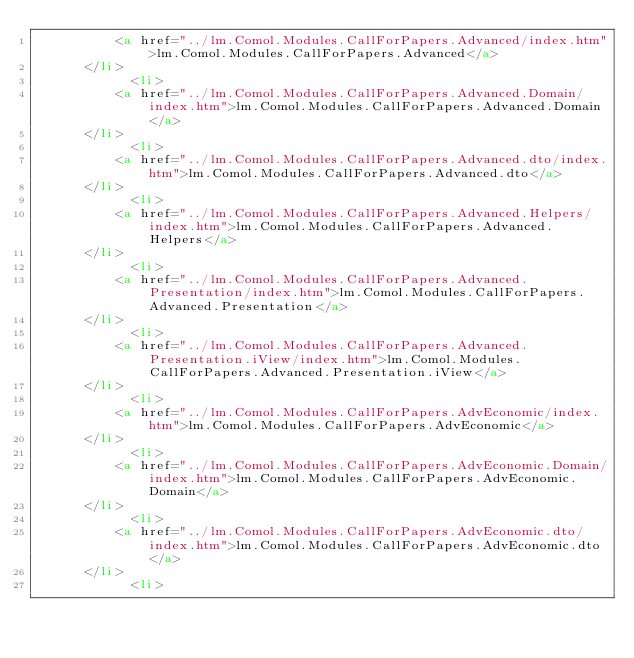<code> <loc_0><loc_0><loc_500><loc_500><_HTML_>          <a href="../lm.Comol.Modules.CallForPapers.Advanced/index.htm">lm.Comol.Modules.CallForPapers.Advanced</a>
      </li>
			<li>
          <a href="../lm.Comol.Modules.CallForPapers.Advanced.Domain/index.htm">lm.Comol.Modules.CallForPapers.Advanced.Domain</a>
      </li>
			<li>
          <a href="../lm.Comol.Modules.CallForPapers.Advanced.dto/index.htm">lm.Comol.Modules.CallForPapers.Advanced.dto</a>
      </li>
			<li>
          <a href="../lm.Comol.Modules.CallForPapers.Advanced.Helpers/index.htm">lm.Comol.Modules.CallForPapers.Advanced.Helpers</a>
      </li>
			<li>
          <a href="../lm.Comol.Modules.CallForPapers.Advanced.Presentation/index.htm">lm.Comol.Modules.CallForPapers.Advanced.Presentation</a>
      </li>
			<li>
          <a href="../lm.Comol.Modules.CallForPapers.Advanced.Presentation.iView/index.htm">lm.Comol.Modules.CallForPapers.Advanced.Presentation.iView</a>
      </li>
			<li>
          <a href="../lm.Comol.Modules.CallForPapers.AdvEconomic/index.htm">lm.Comol.Modules.CallForPapers.AdvEconomic</a>
      </li>
			<li>
          <a href="../lm.Comol.Modules.CallForPapers.AdvEconomic.Domain/index.htm">lm.Comol.Modules.CallForPapers.AdvEconomic.Domain</a>
      </li>
			<li>
          <a href="../lm.Comol.Modules.CallForPapers.AdvEconomic.dto/index.htm">lm.Comol.Modules.CallForPapers.AdvEconomic.dto</a>
      </li>
			<li></code> 